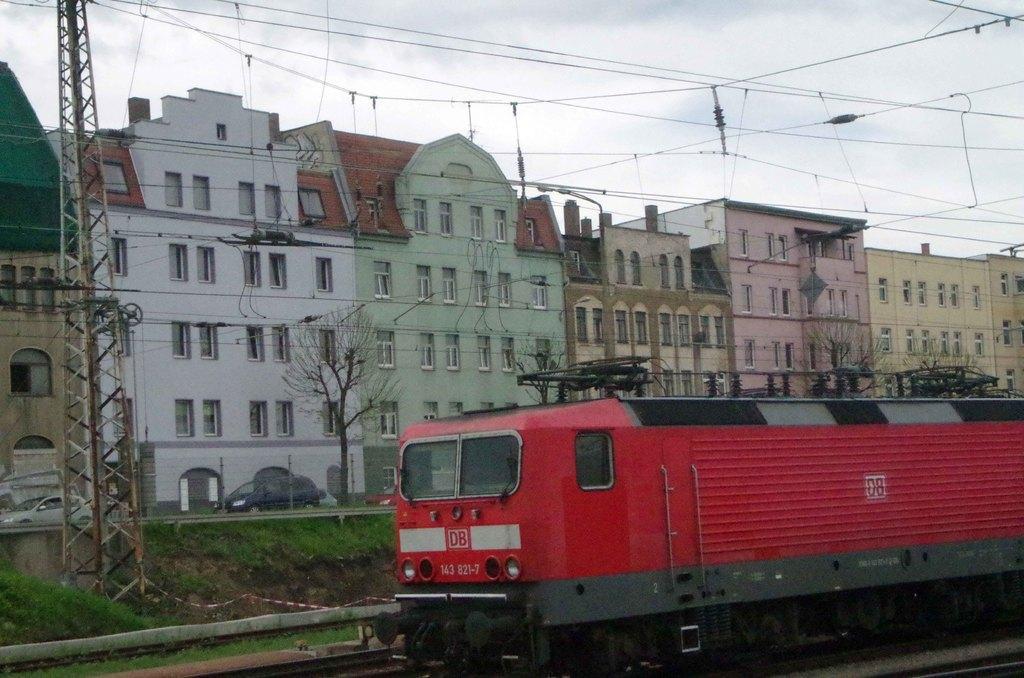Could you give a brief overview of what you see in this image? In the center of the image we can see a train, which is in a red color. In the background, we can see the sky, clouds, buildings, windows, wires, grass, trees, vehicles, one pole type structure and some objects. 